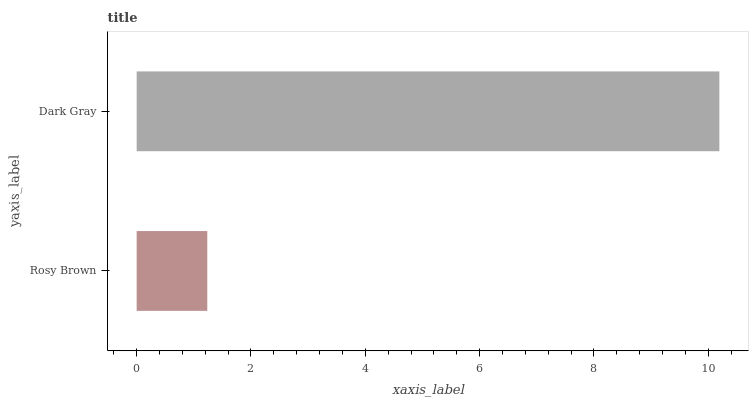Is Rosy Brown the minimum?
Answer yes or no. Yes. Is Dark Gray the maximum?
Answer yes or no. Yes. Is Dark Gray the minimum?
Answer yes or no. No. Is Dark Gray greater than Rosy Brown?
Answer yes or no. Yes. Is Rosy Brown less than Dark Gray?
Answer yes or no. Yes. Is Rosy Brown greater than Dark Gray?
Answer yes or no. No. Is Dark Gray less than Rosy Brown?
Answer yes or no. No. Is Dark Gray the high median?
Answer yes or no. Yes. Is Rosy Brown the low median?
Answer yes or no. Yes. Is Rosy Brown the high median?
Answer yes or no. No. Is Dark Gray the low median?
Answer yes or no. No. 